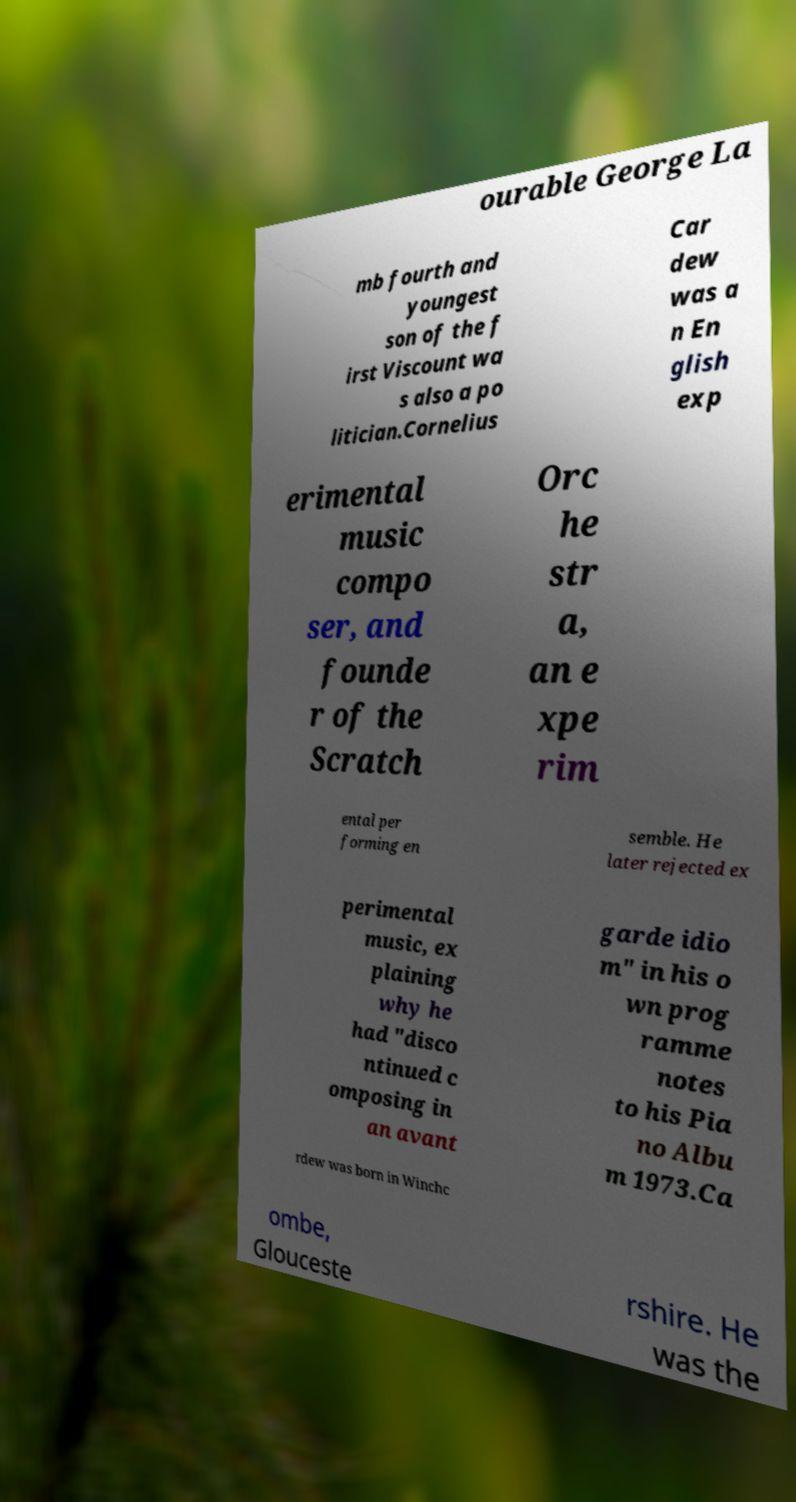For documentation purposes, I need the text within this image transcribed. Could you provide that? ourable George La mb fourth and youngest son of the f irst Viscount wa s also a po litician.Cornelius Car dew was a n En glish exp erimental music compo ser, and founde r of the Scratch Orc he str a, an e xpe rim ental per forming en semble. He later rejected ex perimental music, ex plaining why he had "disco ntinued c omposing in an avant garde idio m" in his o wn prog ramme notes to his Pia no Albu m 1973.Ca rdew was born in Winchc ombe, Glouceste rshire. He was the 